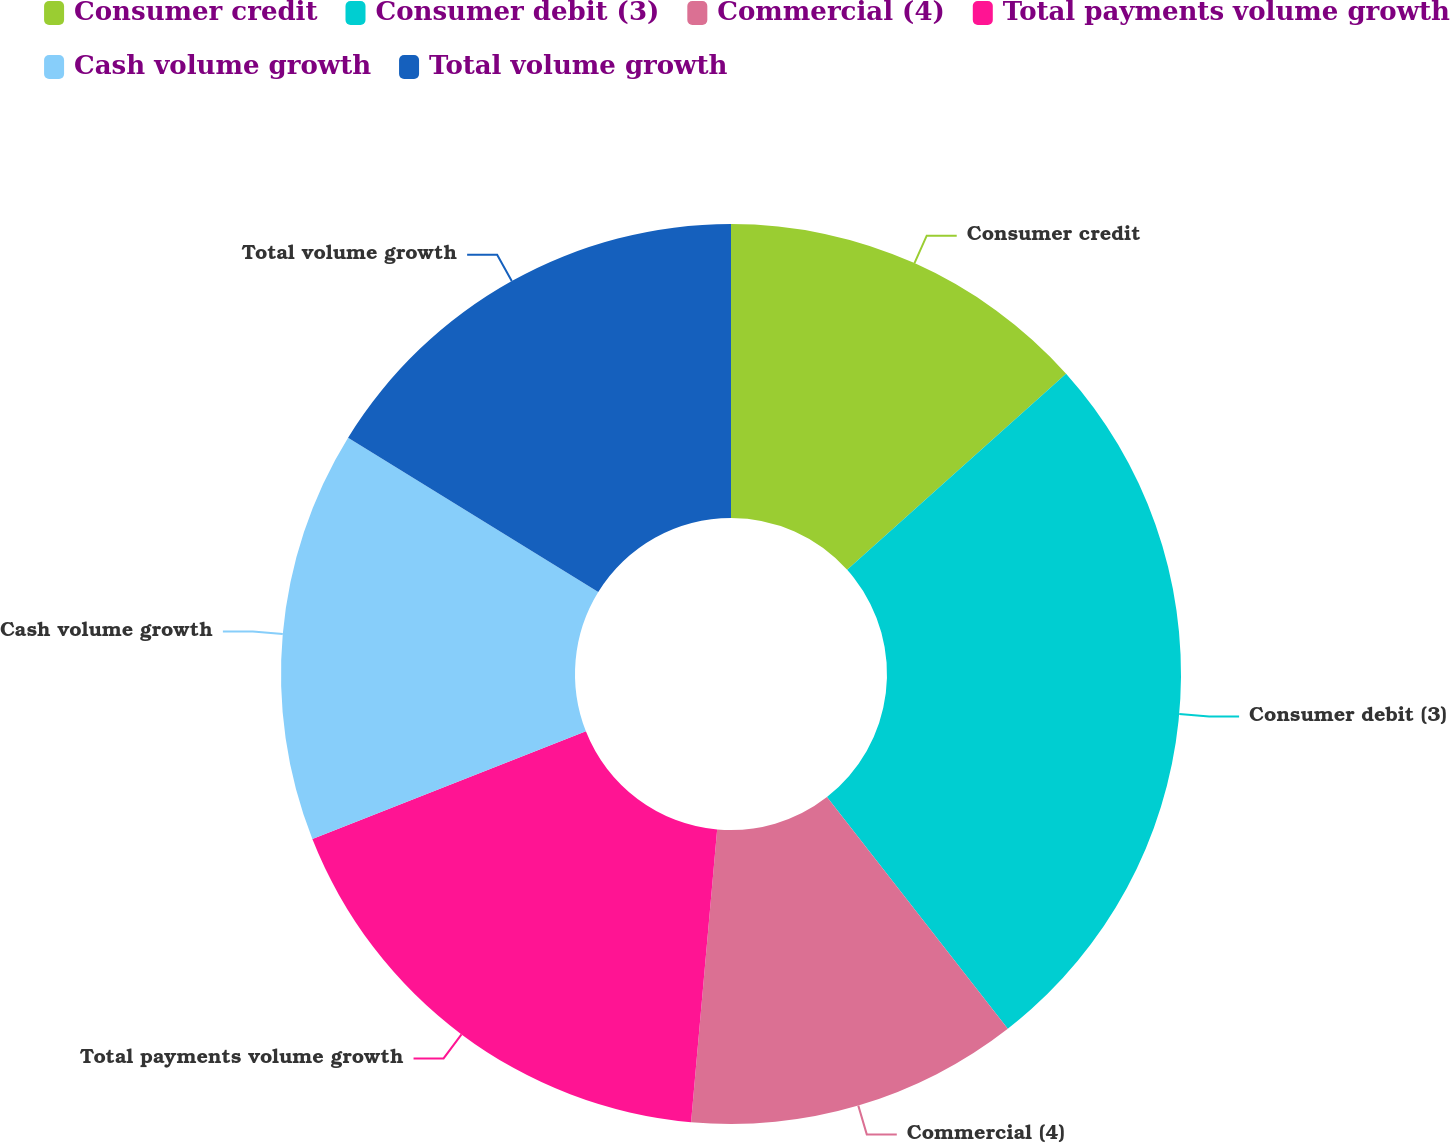Convert chart to OTSL. <chart><loc_0><loc_0><loc_500><loc_500><pie_chart><fcel>Consumer credit<fcel>Consumer debit (3)<fcel>Commercial (4)<fcel>Total payments volume growth<fcel>Cash volume growth<fcel>Total volume growth<nl><fcel>13.37%<fcel>26.09%<fcel>11.96%<fcel>17.61%<fcel>14.78%<fcel>16.2%<nl></chart> 